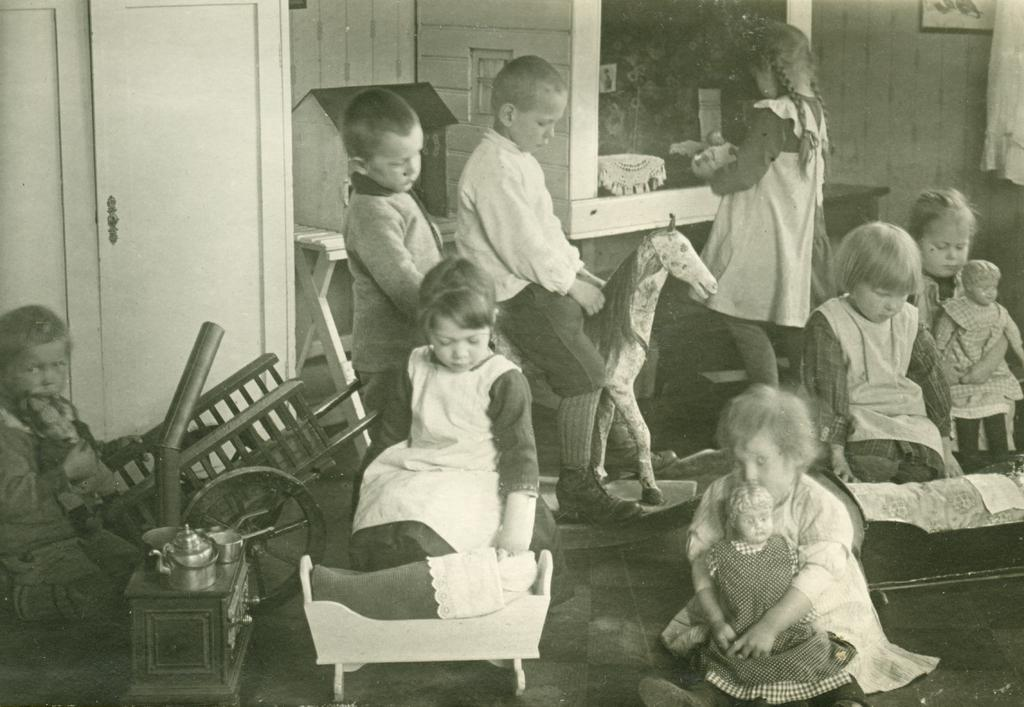What are the kids in the image doing? The kids in the image are playing. What are the kids playing with in the image? The kids are playing with different objects. Can you describe the surroundings in the image? There is a door visible in the image, and there is a wall on the right side of the image. What type of musical instrument is being attacked by the number in the image? There is no musical instrument, attack, or number present in the image. 